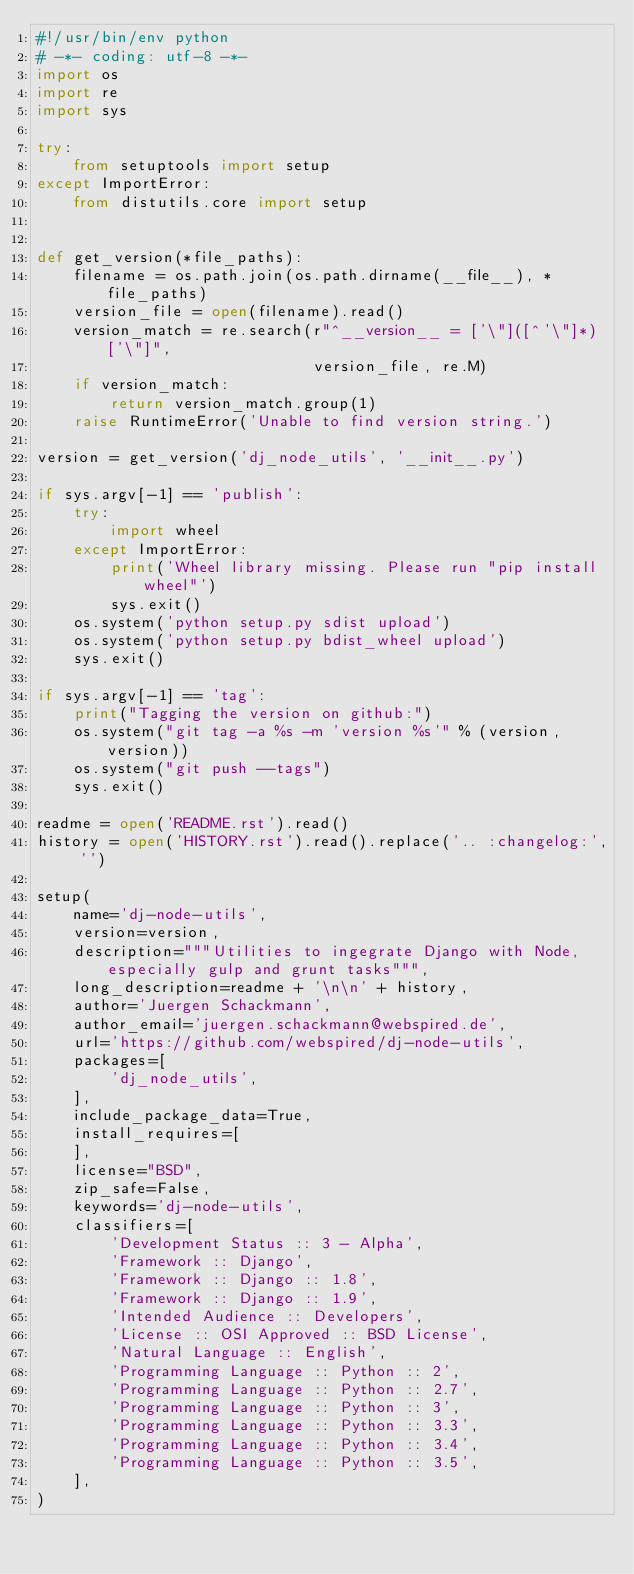<code> <loc_0><loc_0><loc_500><loc_500><_Python_>#!/usr/bin/env python
# -*- coding: utf-8 -*-
import os
import re
import sys

try:
    from setuptools import setup
except ImportError:
    from distutils.core import setup


def get_version(*file_paths):
    filename = os.path.join(os.path.dirname(__file__), *file_paths)
    version_file = open(filename).read()
    version_match = re.search(r"^__version__ = ['\"]([^'\"]*)['\"]",
                              version_file, re.M)
    if version_match:
        return version_match.group(1)
    raise RuntimeError('Unable to find version string.')

version = get_version('dj_node_utils', '__init__.py')

if sys.argv[-1] == 'publish':
    try:
        import wheel
    except ImportError:
        print('Wheel library missing. Please run "pip install wheel"')
        sys.exit()
    os.system('python setup.py sdist upload')
    os.system('python setup.py bdist_wheel upload')
    sys.exit()

if sys.argv[-1] == 'tag':
    print("Tagging the version on github:")
    os.system("git tag -a %s -m 'version %s'" % (version, version))
    os.system("git push --tags")
    sys.exit()

readme = open('README.rst').read()
history = open('HISTORY.rst').read().replace('.. :changelog:', '')

setup(
    name='dj-node-utils',
    version=version,
    description="""Utilities to ingegrate Django with Node, especially gulp and grunt tasks""",
    long_description=readme + '\n\n' + history,
    author='Juergen Schackmann',
    author_email='juergen.schackmann@webspired.de',
    url='https://github.com/webspired/dj-node-utils',
    packages=[
        'dj_node_utils',
    ],
    include_package_data=True,
    install_requires=[
    ],
    license="BSD",
    zip_safe=False,
    keywords='dj-node-utils',
    classifiers=[
        'Development Status :: 3 - Alpha',
        'Framework :: Django',
        'Framework :: Django :: 1.8',
        'Framework :: Django :: 1.9',
        'Intended Audience :: Developers',
        'License :: OSI Approved :: BSD License',
        'Natural Language :: English',
        'Programming Language :: Python :: 2',
        'Programming Language :: Python :: 2.7',
        'Programming Language :: Python :: 3',
        'Programming Language :: Python :: 3.3',
        'Programming Language :: Python :: 3.4',
        'Programming Language :: Python :: 3.5',
    ],
)
</code> 